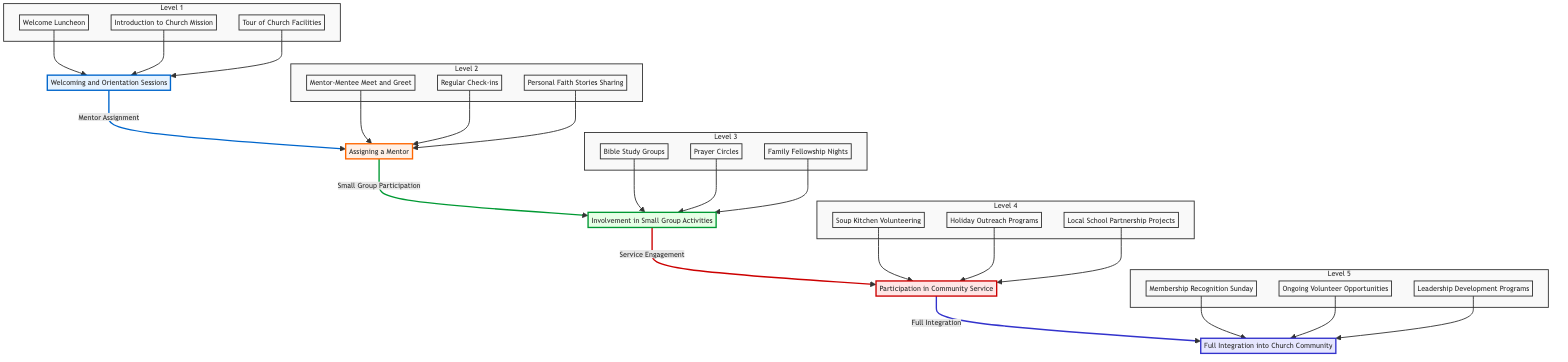What is the title of the first step in the integration process? The first step in the integration process is indicated in the lowest node and is titled "Welcoming and Orientation Sessions."
Answer: Welcoming and Orientation Sessions How many levels are represented in the diagram? By counting the distinct steps, there are five levels in the integration process as shown by the nodes moving from the bottom to the top.
Answer: 5 What activities are included in "Involvement in Small Group Activities"? The activities listed under "Involvement in Small Group Activities" include "Bible Study Groups," "Prayer Circles," and "Family Fellowship Nights."
Answer: Bible Study Groups, Prayer Circles, Family Fellowship Nights What connects "Assigning a Mentor" to "Involvement in Small Group Activities"? The connection between "Assigning a Mentor" and "Involvement in Small Group Activities" is described by the term "Small Group Participation."
Answer: Small Group Participation Which level involves participation in community service? The level that specifically involves participation in community service is labeled as Level 4, titled "Participation in Community Service."
Answer: Participation in Community Service What is the relationship between the "Welcoming and Orientation Sessions" and "Full Integration into Church Community"? The relationship shows a direct progression from "Welcoming and Orientation Sessions" at the bottom to "Full Integration into Church Community" at the top, indicating that the latter is the ultimate goal to achieve through the steps in between.
Answer: Progressive relationship What activities occur at the final level of integration? The final level of integration includes activities like "Membership Recognition Sunday," "Ongoing Volunteer Opportunities," and "Leadership Development Programs."
Answer: Membership Recognition Sunday, Ongoing Volunteer Opportunities, Leadership Development Programs What are the intermediary steps between welcoming and full integration? The intermediary steps between welcoming and full integration are "Assigning a Mentor," "Involvement in Small Group Activities," and "Participation in Community Service."
Answer: Assigning a Mentor, Involvement in Small Group Activities, Participation in Community Service What level is directly above "Assigning a Mentor"? The level directly above "Assigning a Mentor" is titled "Involvement in Small Group Activities."
Answer: Involvement in Small Group Activities 